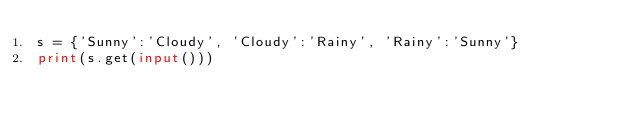Convert code to text. <code><loc_0><loc_0><loc_500><loc_500><_Python_>s = {'Sunny':'Cloudy', 'Cloudy':'Rainy', 'Rainy':'Sunny'}
print(s.get(input()))</code> 